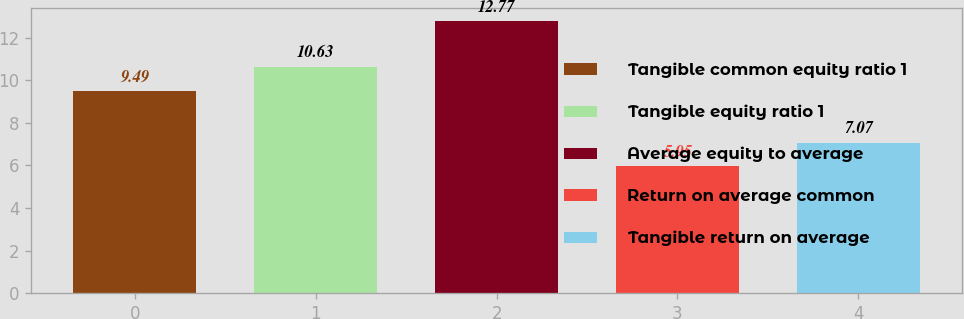<chart> <loc_0><loc_0><loc_500><loc_500><bar_chart><fcel>Tangible common equity ratio 1<fcel>Tangible equity ratio 1<fcel>Average equity to average<fcel>Return on average common<fcel>Tangible return on average<nl><fcel>9.49<fcel>10.63<fcel>12.77<fcel>5.95<fcel>7.07<nl></chart> 